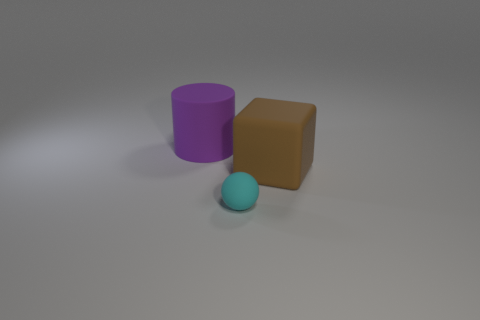What number of tiny things are either red matte cylinders or brown objects?
Provide a succinct answer. 0. What shape is the large matte thing behind the brown rubber cube?
Your response must be concise. Cylinder. Is there a large rubber object that has the same color as the block?
Provide a succinct answer. No. Does the rubber cylinder on the left side of the brown cube have the same size as the thing that is to the right of the cyan object?
Make the answer very short. Yes. Is the number of small spheres that are to the right of the tiny ball greater than the number of brown rubber blocks on the right side of the cube?
Your answer should be very brief. No. Is there a tiny thing that has the same material as the big cube?
Give a very brief answer. Yes. Do the small thing and the large cylinder have the same color?
Ensure brevity in your answer.  No. There is a object that is behind the tiny cyan sphere and left of the large rubber cube; what is it made of?
Provide a succinct answer. Rubber. The tiny sphere has what color?
Ensure brevity in your answer.  Cyan. What number of purple rubber objects are the same shape as the big brown thing?
Keep it short and to the point. 0. 